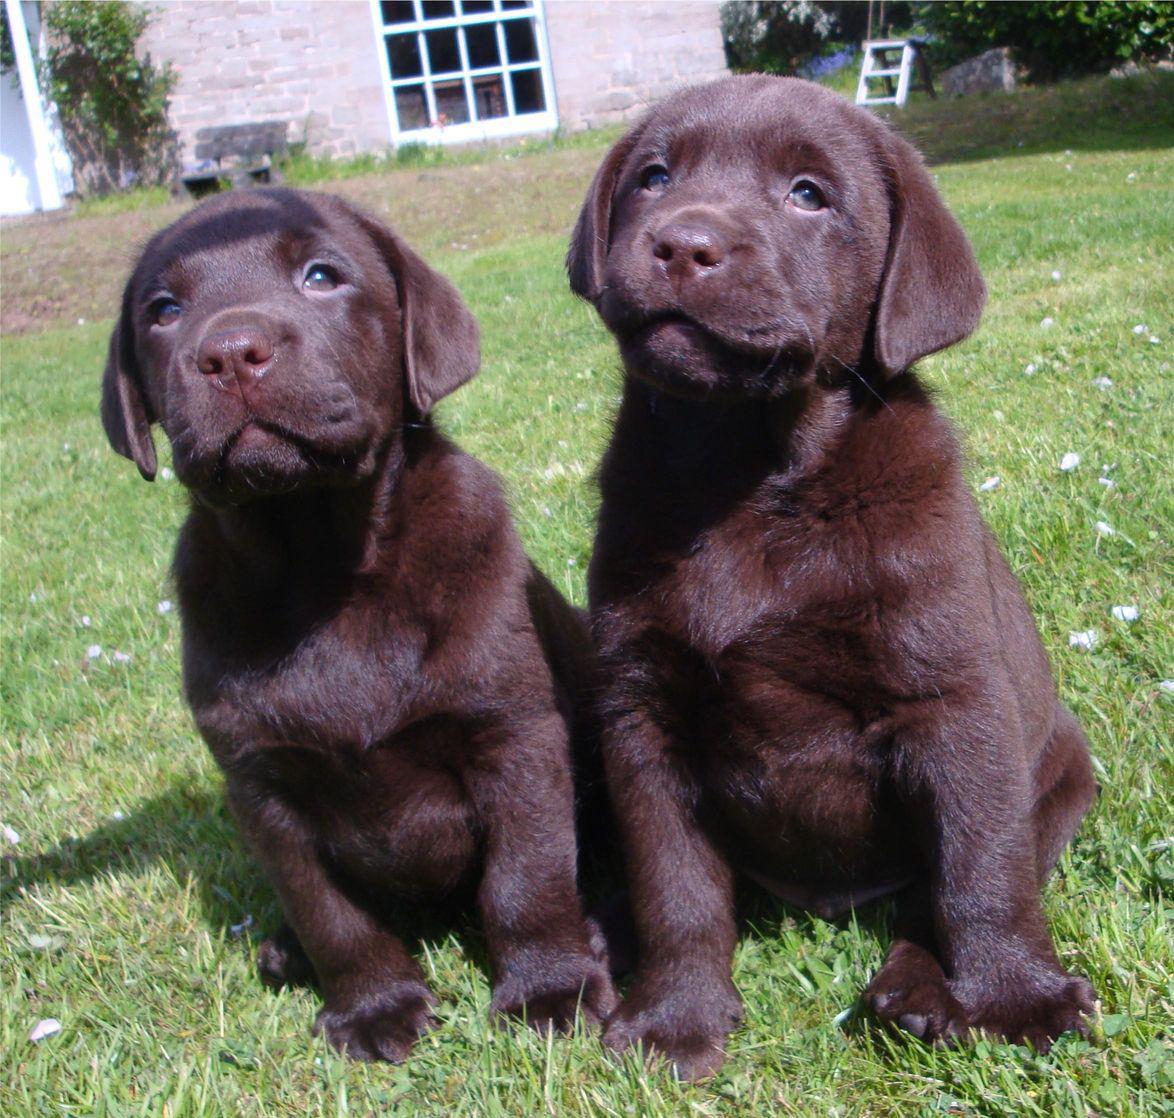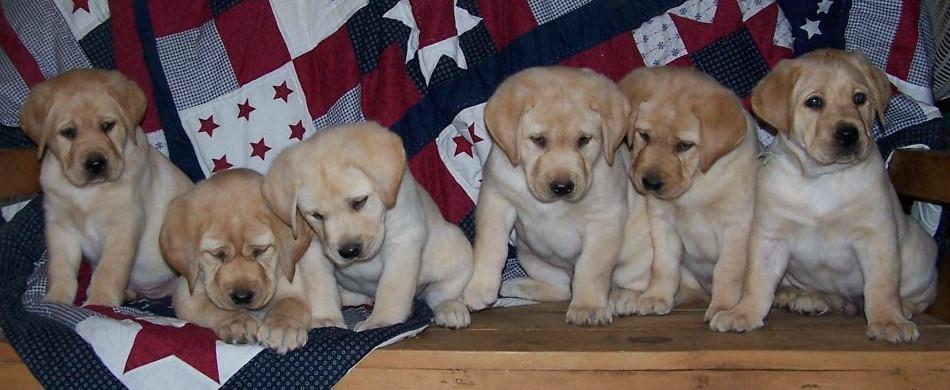The first image is the image on the left, the second image is the image on the right. For the images shown, is this caption "Each image shows one forward-facing young dog, and the dogs in the left and right images have dark fur color." true? Answer yes or no. No. 